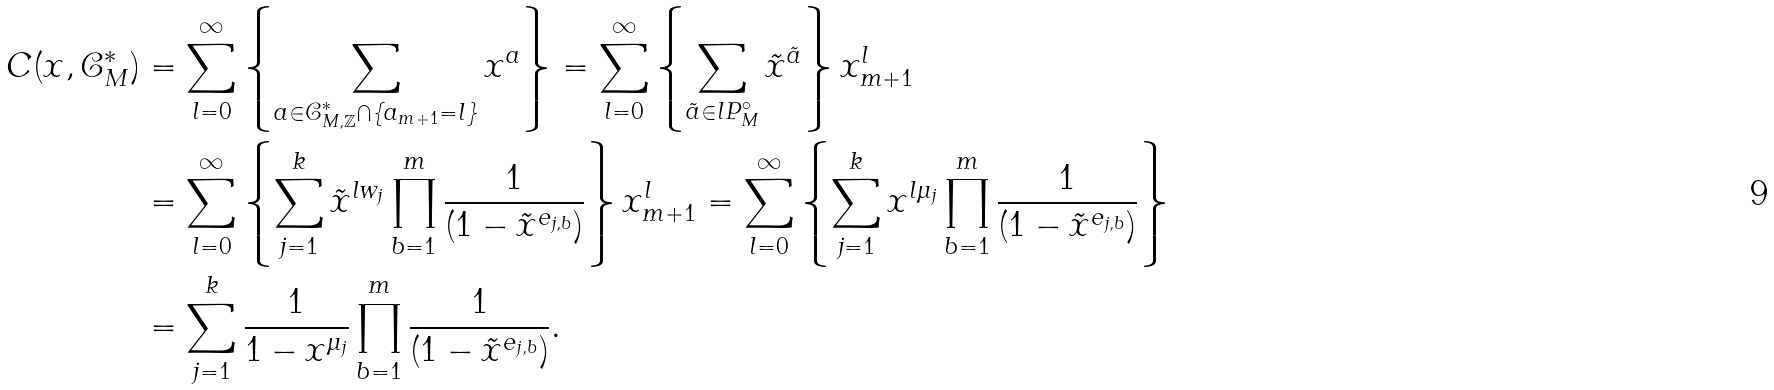Convert formula to latex. <formula><loc_0><loc_0><loc_500><loc_500>C ( { x } , \mathcal { C } _ { M } ^ { * } ) & = \sum _ { l = 0 } ^ { \infty } \left \{ \sum _ { { a } \in \mathcal { C } ^ { * } _ { M , \mathbb { Z } } \cap \{ a _ { m + 1 } = l \} } { x } ^ { a } \right \} = \sum _ { l = 0 } ^ { \infty } \left \{ \sum _ { \tilde { a } \in l P ^ { \circ } _ { M } } \tilde { x } ^ { \tilde { a } } \right \} x _ { m + 1 } ^ { l } \\ & = \sum _ { l = 0 } ^ { \infty } \left \{ \sum _ { j = 1 } ^ { k } \tilde { x } ^ { l { w } _ { j } } \prod _ { b = 1 } ^ { m } \frac { 1 } { ( 1 - \tilde { x } ^ { { e } _ { j , b } } ) } \right \} x _ { m + 1 } ^ { l } = \sum _ { l = 0 } ^ { \infty } \left \{ \sum _ { j = 1 } ^ { k } { x } ^ { l \mu _ { j } } \prod _ { b = 1 } ^ { m } \frac { 1 } { ( 1 - \tilde { x } ^ { { e } _ { j , b } } ) } \right \} \\ & = \sum _ { j = 1 } ^ { k } \frac { 1 } { 1 - { x } ^ { \mu _ { j } } } \prod _ { b = 1 } ^ { m } \frac { 1 } { ( 1 - \tilde { x } ^ { { e } _ { j , b } } ) } .</formula> 